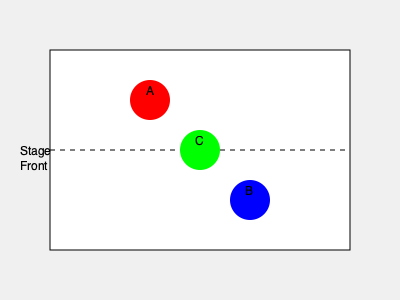As a casting director working with a former child star to create a dynamic stage composition, which actor should be positioned at point C to create the most balanced triangular formation? To create a dynamic and balanced stage composition, we need to consider the following steps:

1. Observe the current positioning: Actor A is upstage left, and Actor B is downstage right.

2. Identify the triangular formation: Points A, B, and C form a triangle on the stage.

3. Understand balance in composition: A balanced triangular formation should have actors of varying heights or visual weights distributed evenly.

4. Consider the characteristics of the former child star:
   a) They likely have a smaller stature compared to adult actors.
   b) Their presence may draw more attention due to their fame.

5. Analyze point C's position: It's center stage, which is typically a position of power or focus.

6. Make the decision:
   - Placing the former child star at point C would create an imbalance, as their smaller stature and high recognition might overwhelm the composition.
   - A taller or more physically imposing actor at point C would create a more balanced triangle, offsetting the former child star's position at either A or B.

7. Conclude: The most balanced formation would be achieved by positioning the former child star at either point A or B, and placing a taller or more physically imposing actor at point C.
Answer: A taller or more physically imposing actor 